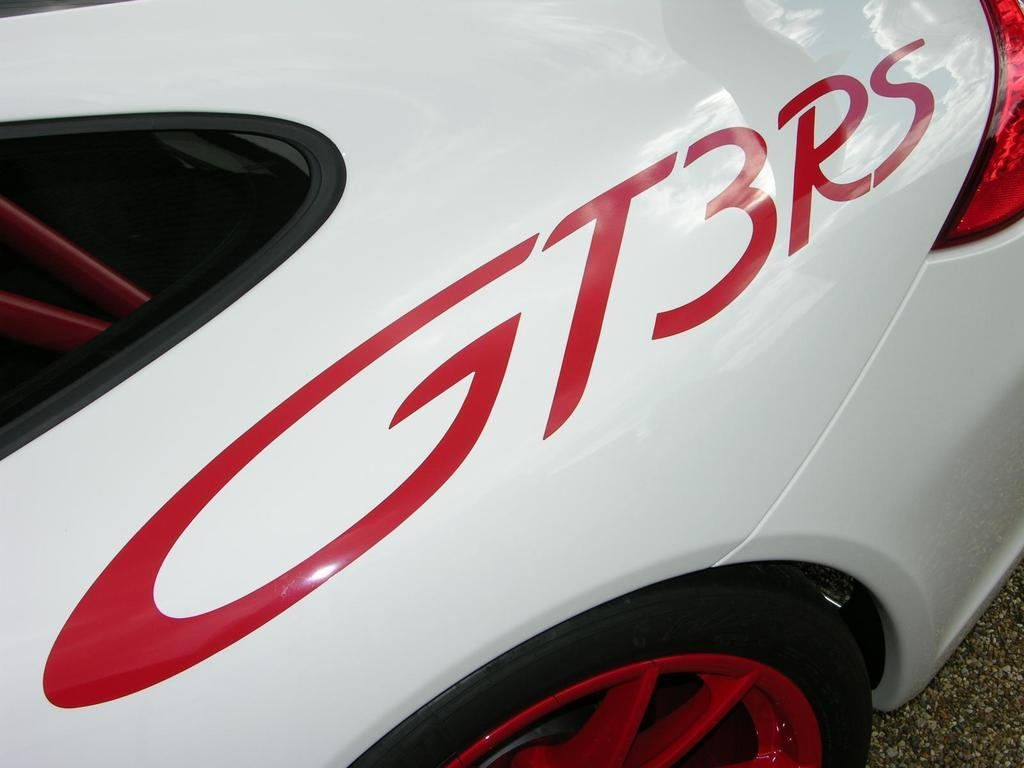What is the main subject of the image? There is a car in the image. What is the car situated on or near? There is a road visible at the bottom of the image. Can you see the cow looking at the car in the image? There is no cow present in the image, so it cannot be seen looking at the car. 